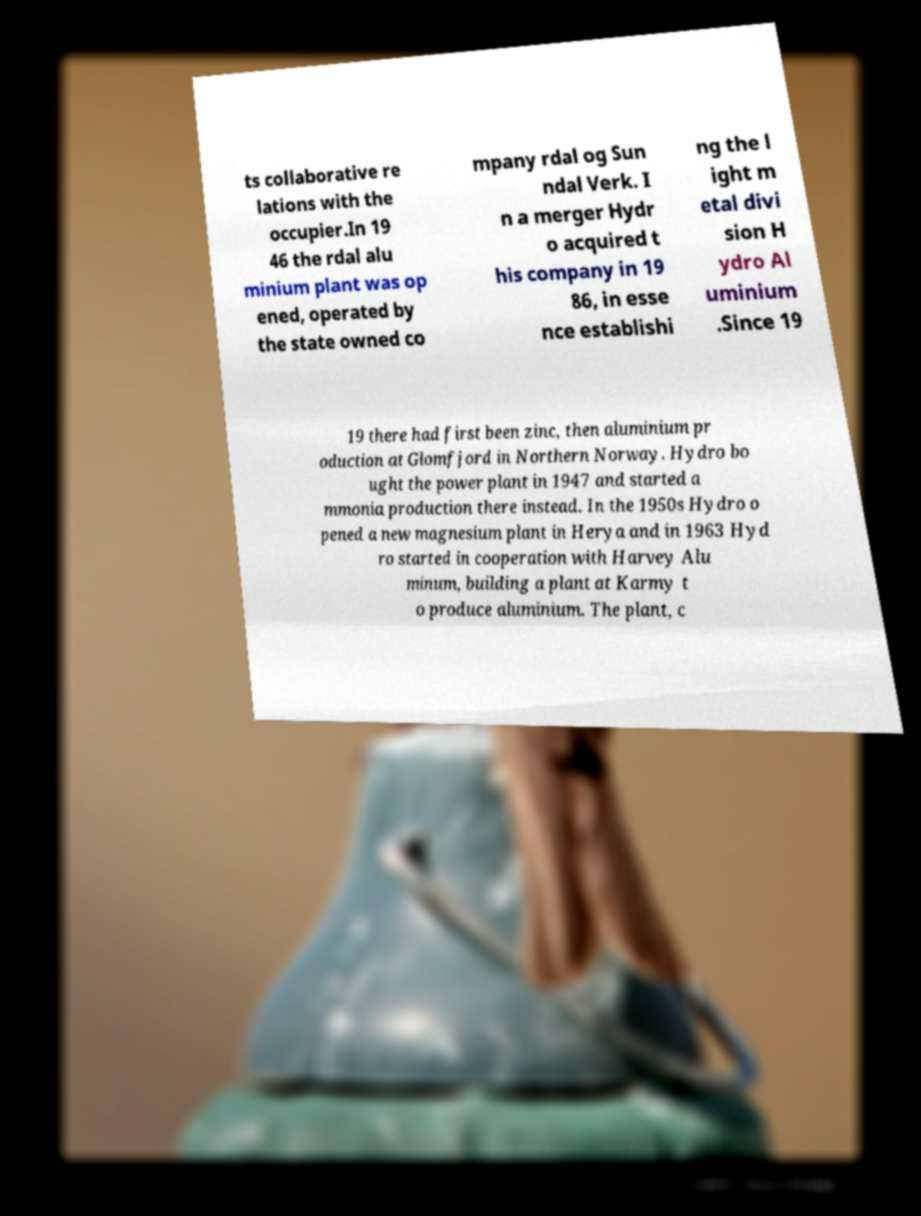Can you read and provide the text displayed in the image?This photo seems to have some interesting text. Can you extract and type it out for me? ts collaborative re lations with the occupier.In 19 46 the rdal alu minium plant was op ened, operated by the state owned co mpany rdal og Sun ndal Verk. I n a merger Hydr o acquired t his company in 19 86, in esse nce establishi ng the l ight m etal divi sion H ydro Al uminium .Since 19 19 there had first been zinc, then aluminium pr oduction at Glomfjord in Northern Norway. Hydro bo ught the power plant in 1947 and started a mmonia production there instead. In the 1950s Hydro o pened a new magnesium plant in Herya and in 1963 Hyd ro started in cooperation with Harvey Alu minum, building a plant at Karmy t o produce aluminium. The plant, c 